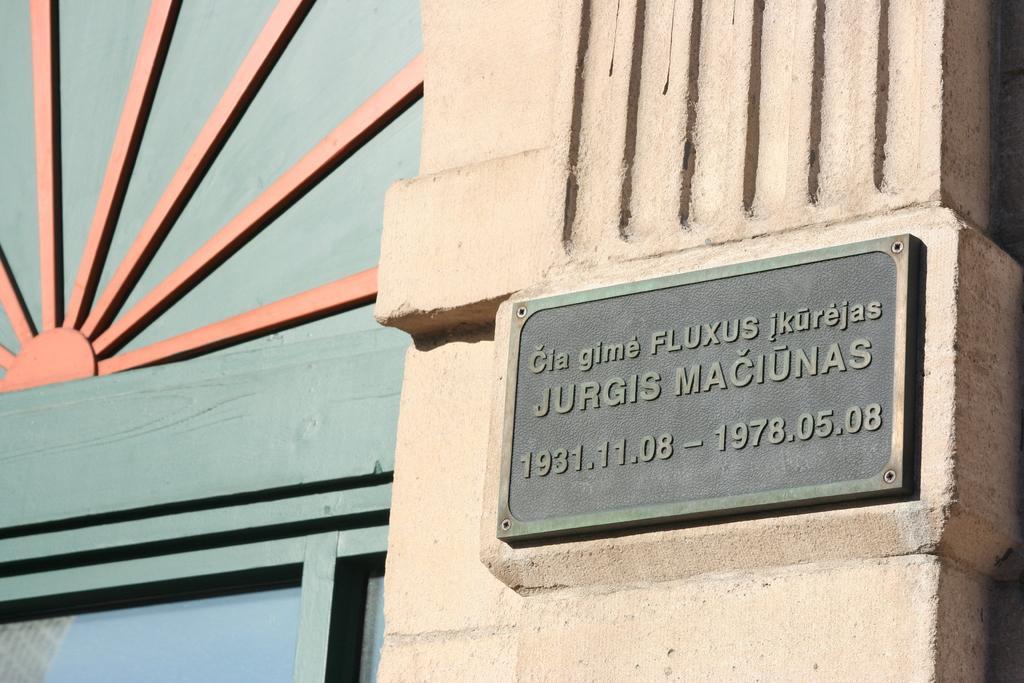Can you describe this image briefly? In this picture there is a building and there is a board on the wall and there is text on the board. At the bottom there might be a window. There is reflection of building and sky on the glass. 